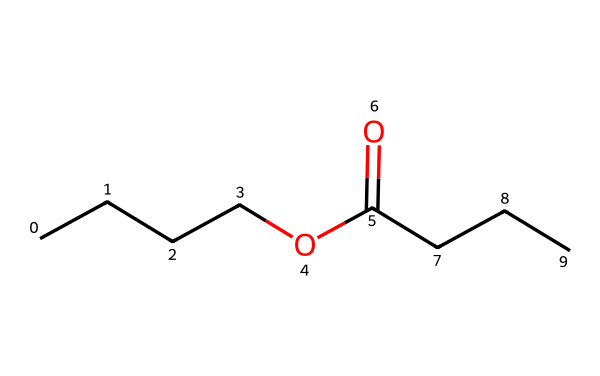What is the main functional group present in butyl butyrate? The main functional group in butyl butyrate is an ester, which can be identified by the presence of a carbonyl (C=O) followed by an alkoxy group (O attached to a carbon).
Answer: ester How many carbon atoms are in butyl butyrate? By examining the SMILES representation, "CCCC" indicates 4 carbons in the butyl part, and "CCC" indicates 3 more carbons in the butyrate part, totaling 7 carbons.
Answer: seven What are the two distinct parts of the ester in butyl butyrate? Butyl butyrate consists of two parts: the butyl group derived from butanol (CCCC) and the butyrate group derived from butyric acid (C(=O)CCC).
Answer: butyl and butyrate Identify the type of bond that connects the carbonyl carbon to the oxygen in butyl butyrate. The bond connecting the carbonyl carbon to the oxygen is a single bond, as indicated by the presence of the ester functional group where carbon (C) is directly bonded to the oxygen (O) of the alkoxy part.
Answer: single bond What is butyl butyrate commonly used for? Butyl butyrate is commonly used for its pineapple fragrance in flavorings and perfumes, as it has a fruity aroma resembling that of pineapple.
Answer: fragrance How does the structure of butyl butyrate suggest its volatility? The lower molecular weight of butyl butyrate (compared to heavier chains) and its ester functional group typically lend themselves to higher volatility, which can be inferred from the relatively simple structure.
Answer: higher volatility 